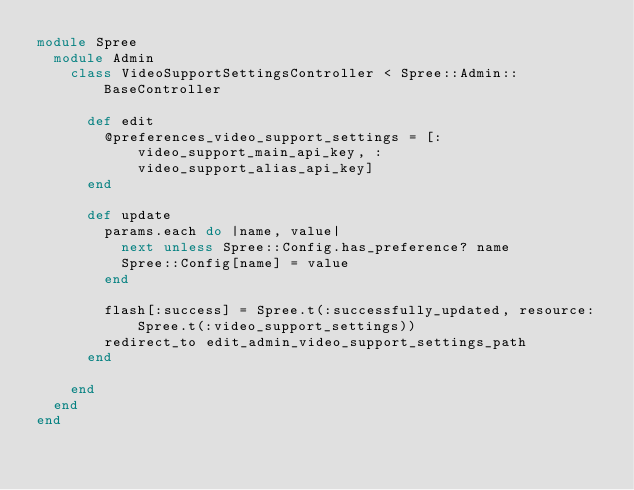Convert code to text. <code><loc_0><loc_0><loc_500><loc_500><_Ruby_>module Spree
  module Admin
    class VideoSupportSettingsController < Spree::Admin::BaseController

      def edit
        @preferences_video_support_settings = [:video_support_main_api_key, :video_support_alias_api_key]
      end

      def update
        params.each do |name, value|
          next unless Spree::Config.has_preference? name
          Spree::Config[name] = value
        end

        flash[:success] = Spree.t(:successfully_updated, resource: Spree.t(:video_support_settings))
        redirect_to edit_admin_video_support_settings_path
      end

    end
  end
end
</code> 